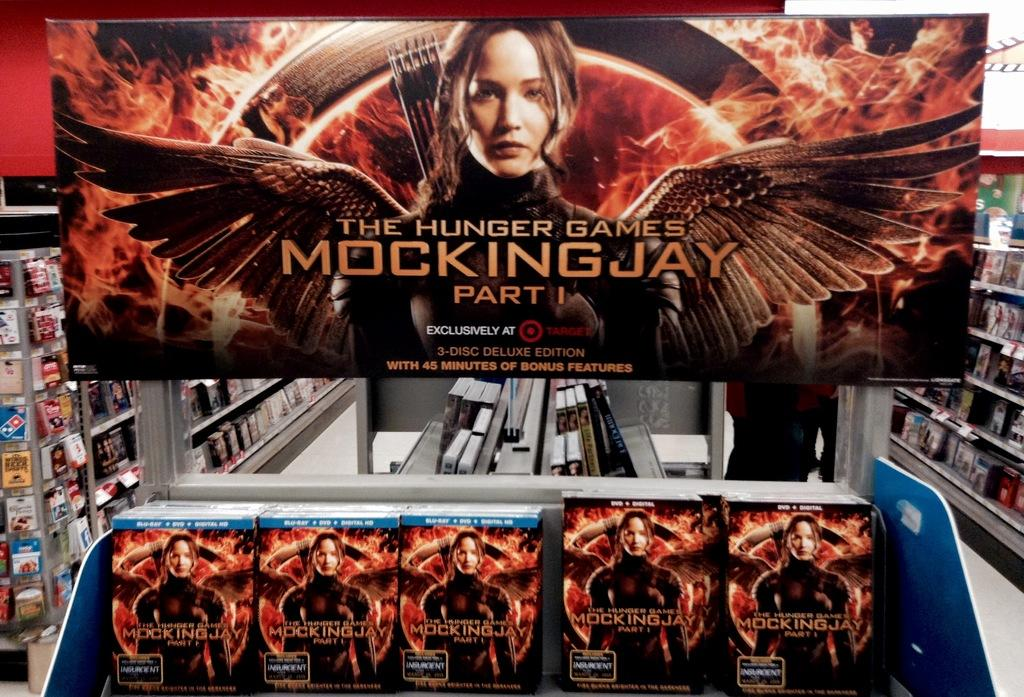<image>
Present a compact description of the photo's key features. A DVD and blu-ray display for the Hunger Games Mockingjay Part I has a large banner. 